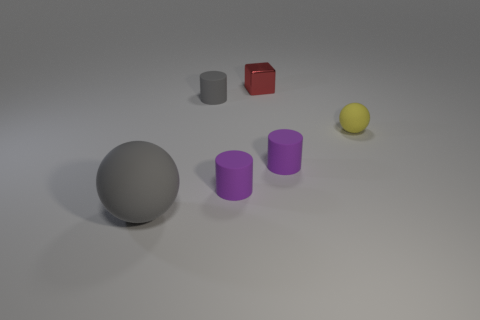Add 4 small cyan shiny blocks. How many objects exist? 10 Subtract all blocks. How many objects are left? 5 Subtract all cyan cubes. Subtract all metal cubes. How many objects are left? 5 Add 5 tiny matte things. How many tiny matte things are left? 9 Add 1 gray rubber things. How many gray rubber things exist? 3 Subtract 0 green cylinders. How many objects are left? 6 